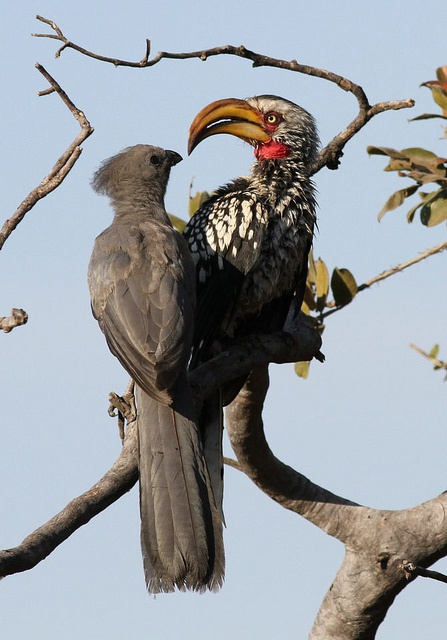Describe the objects in this image and their specific colors. I can see bird in lightblue, gray, and black tones and bird in lightblue, black, gray, maroon, and beige tones in this image. 